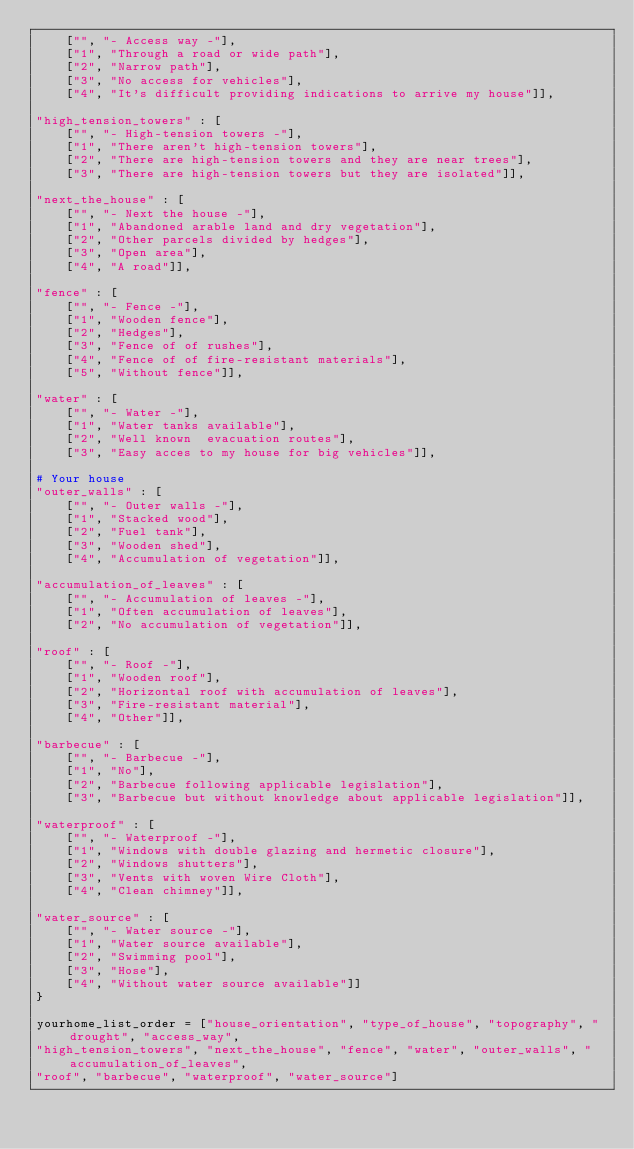Convert code to text. <code><loc_0><loc_0><loc_500><loc_500><_Python_>    ["", "- Access way -"],
    ["1", "Through a road or wide path"],
    ["2", "Narrow path"],
    ["3", "No access for vehicles"],
    ["4", "It's difficult providing indications to arrive my house"]],

"high_tension_towers" : [
    ["", "- High-tension towers -"],
    ["1", "There aren't high-tension towers"],
    ["2", "There are high-tension towers and they are near trees"],
    ["3", "There are high-tension towers but they are isolated"]],

"next_the_house" : [
    ["", "- Next the house -"],
    ["1", "Abandoned arable land and dry vegetation"],
    ["2", "Other parcels divided by hedges"],
    ["3", "Open area"],
    ["4", "A road"]],

"fence" : [
    ["", "- Fence -"],
    ["1", "Wooden fence"],
    ["2", "Hedges"],
    ["3", "Fence of of rushes"],
    ["4", "Fence of of fire-resistant materials"],
    ["5", "Without fence"]],

"water" : [
    ["", "- Water -"],
    ["1", "Water tanks available"],
    ["2", "Well known  evacuation routes"],
    ["3", "Easy acces to my house for big vehicles"]],

# Your house
"outer_walls" : [
    ["", "- Outer walls -"],
    ["1", "Stacked wood"],
    ["2", "Fuel tank"],
    ["3", "Wooden shed"],
    ["4", "Accumulation of vegetation"]],

"accumulation_of_leaves" : [
    ["", "- Accumulation of leaves -"],
    ["1", "Often accumulation of leaves"],
    ["2", "No accumulation of vegetation"]],

"roof" : [
    ["", "- Roof -"],
    ["1", "Wooden roof"],
    ["2", "Horizontal roof with accumulation of leaves"],
    ["3", "Fire-resistant material"],
    ["4", "Other"]],

"barbecue" : [
    ["", "- Barbecue -"],
    ["1", "No"],
    ["2", "Barbecue following applicable legislation"],
    ["3", "Barbecue but without knowledge about applicable legislation"]],

"waterproof" : [
    ["", "- Waterproof -"],
    ["1", "Windows with double glazing and hermetic closure"],
    ["2", "Windows shutters"],
    ["3", "Vents with woven Wire Cloth"],
    ["4", "Clean chimney"]],

"water_source" : [
    ["", "- Water source -"],
    ["1", "Water source available"],
    ["2", "Swimming pool"],
    ["3", "Hose"],
    ["4", "Without water source available"]]
}

yourhome_list_order = ["house_orientation", "type_of_house", "topography", "drought", "access_way",
"high_tension_towers", "next_the_house", "fence", "water", "outer_walls", "accumulation_of_leaves",
"roof", "barbecue", "waterproof", "water_source"]
</code> 